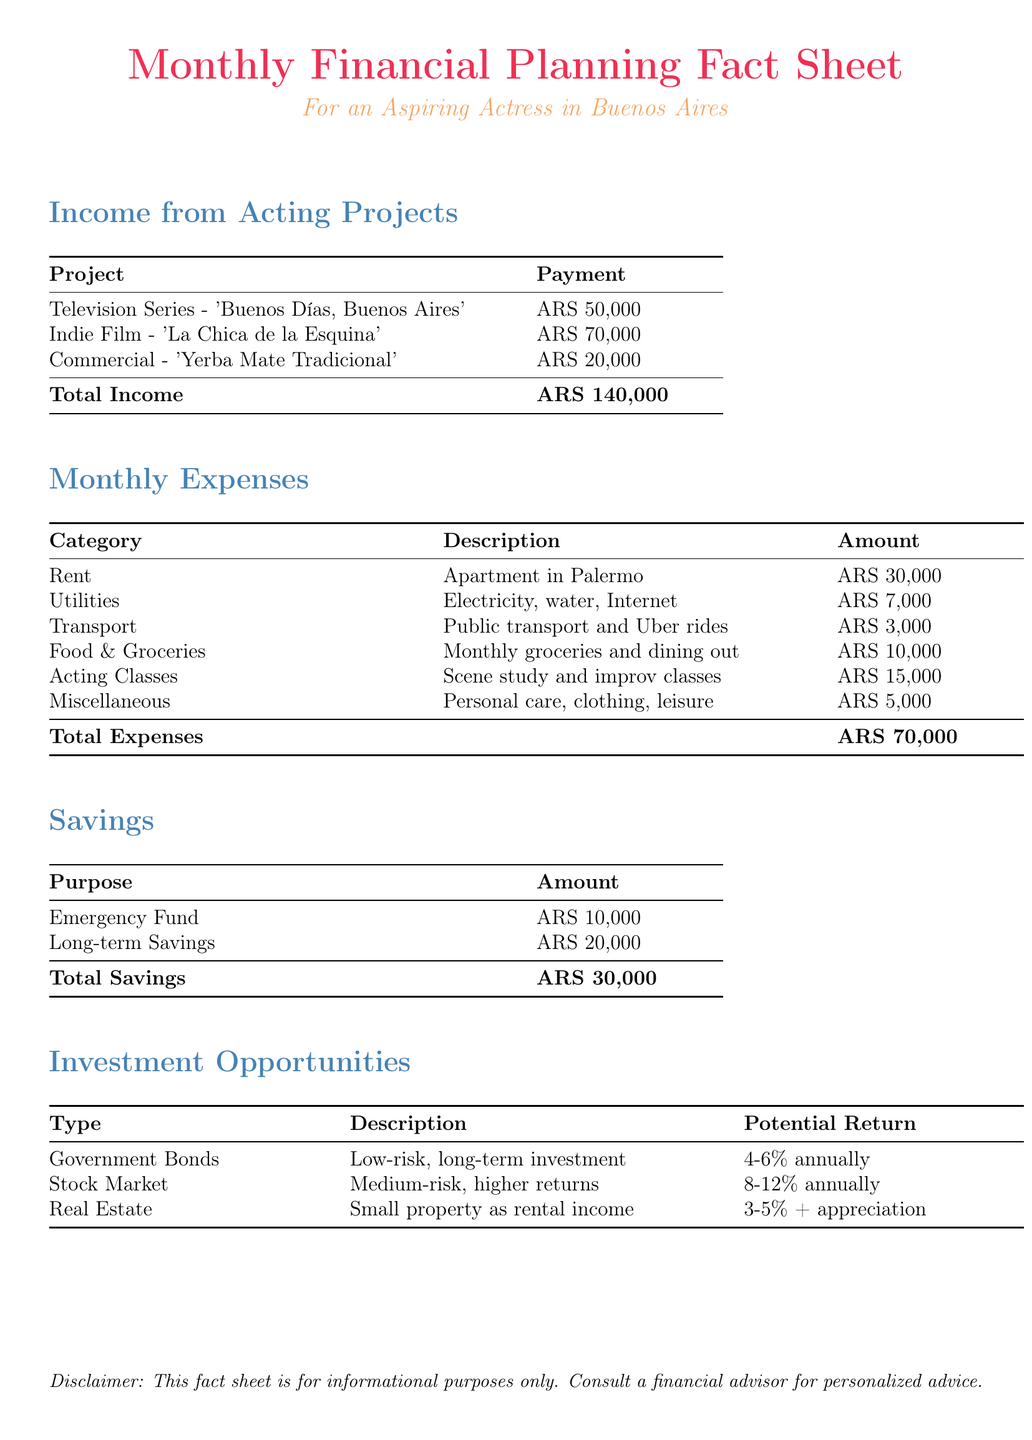What is the total income from acting projects? The total income is the sum of all payments received from acting projects, which are ARS 50,000, ARS 70,000, and ARS 20,000.
Answer: ARS 140,000 How much is spent on acting classes? The document lists a specific amount allocated for acting classes, which is ARS 15,000.
Answer: ARS 15,000 What is the amount allocated for the emergency fund? The emergency fund is specifically stated in the savings section, which amounts to ARS 10,000.
Answer: ARS 10,000 Which project has the highest payment? By comparing all the acting projects listed, the 'Indie Film - La Chica de la Esquina' has the highest payment at ARS 70,000.
Answer: Indie Film - 'La Chica de la Esquina' What is the total of monthly expenses? The total of monthly expenses is calculated as the sum of all expenses listed, which amounts to ARS 70,000.
Answer: ARS 70,000 What is the potential return of investing in the stock market? The potential return for stock market investments is specified in the investment opportunities section as an annual percentage.
Answer: 8-12% annually How much is spent on food and groceries? The document lists food and groceries expenses as ARS 10,000 in the monthly expenses section.
Answer: ARS 10,000 What type of investment is considered low-risk? Among the investment opportunities mentioned, government bonds are categorized as low-risk investments.
Answer: Government Bonds 